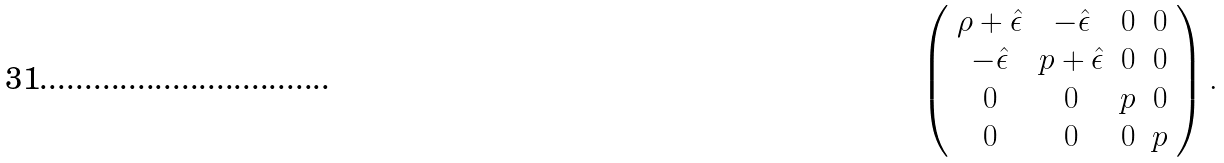<formula> <loc_0><loc_0><loc_500><loc_500>\left ( \begin{array} { c c c c } \rho + \hat { \epsilon } & - \hat { \epsilon } & 0 & 0 \\ - \hat { \epsilon } & p + \hat { \epsilon } & 0 & 0 \\ 0 & 0 & p & 0 \\ 0 & 0 & 0 & p \end{array} \right ) .</formula> 